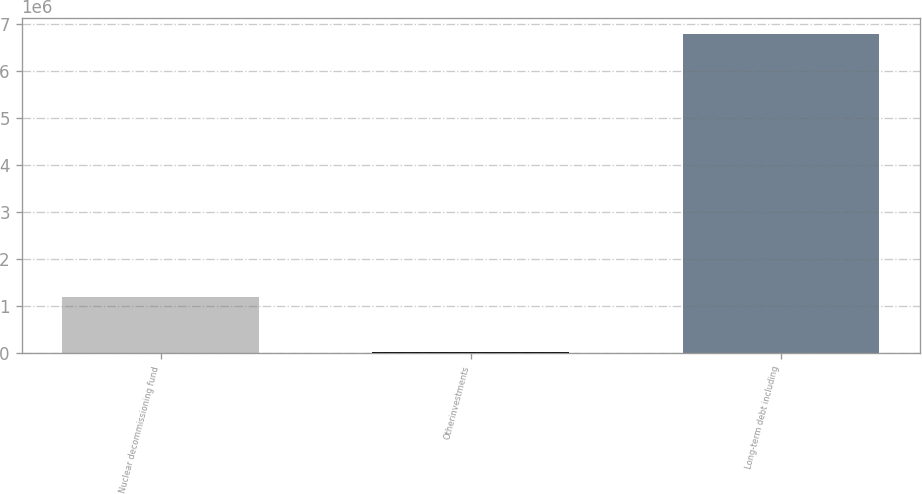<chart> <loc_0><loc_0><loc_500><loc_500><bar_chart><fcel>Nuclear decommissioning fund<fcel>Otherinvestments<fcel>Long-term debt including<nl><fcel>1.20069e+06<fcel>29209<fcel>6.78605e+06<nl></chart> 